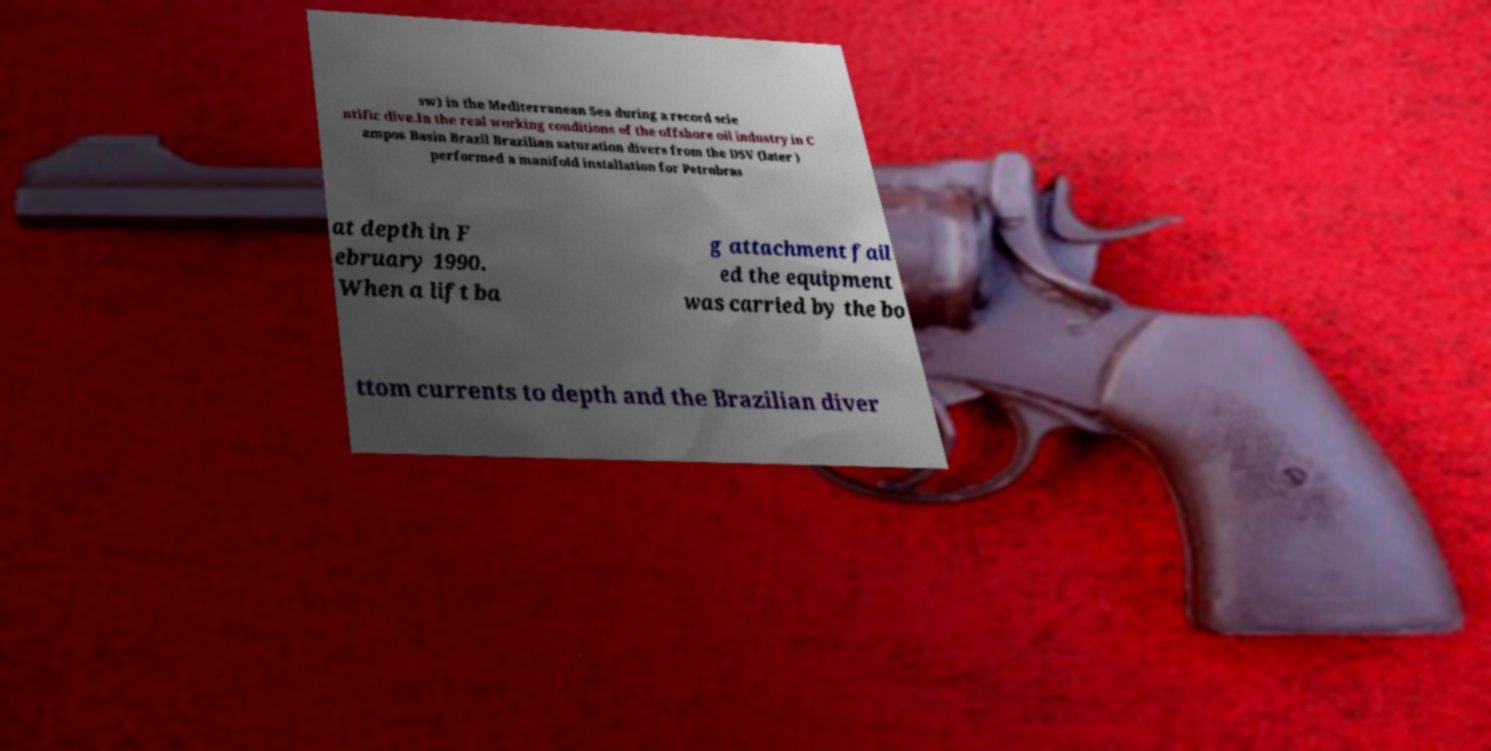There's text embedded in this image that I need extracted. Can you transcribe it verbatim? sw) in the Mediterranean Sea during a record scie ntific dive.In the real working conditions of the offshore oil industry in C ampos Basin Brazil Brazilian saturation divers from the DSV (later ) performed a manifold installation for Petrobras at depth in F ebruary 1990. When a lift ba g attachment fail ed the equipment was carried by the bo ttom currents to depth and the Brazilian diver 